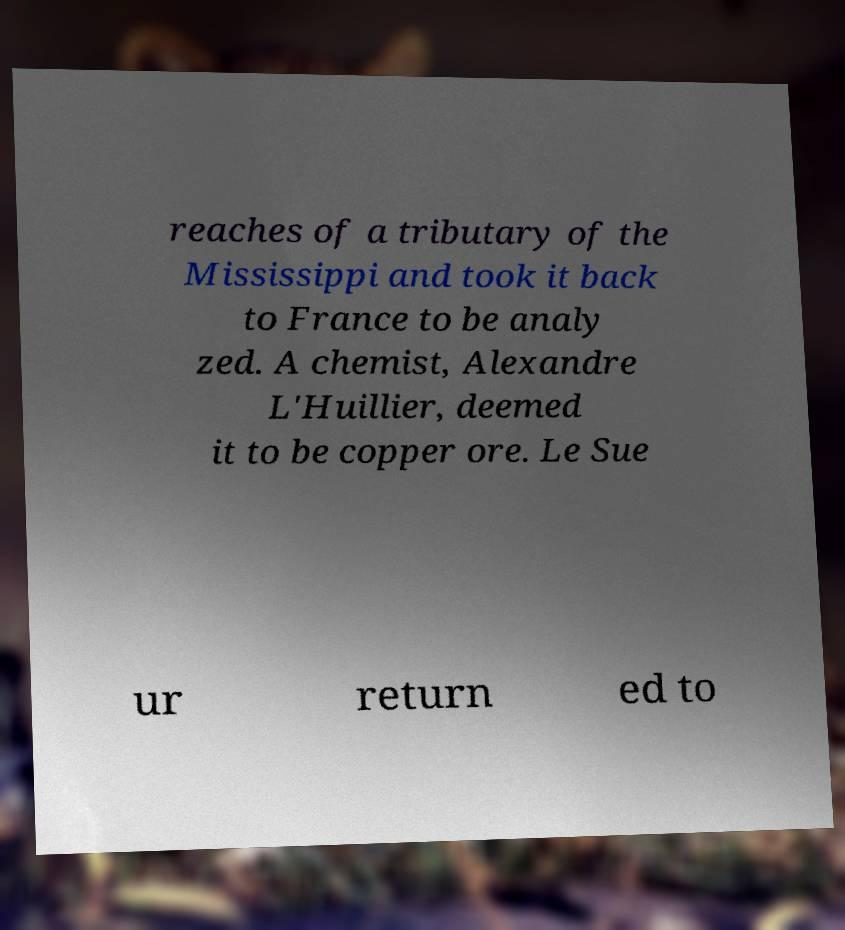For documentation purposes, I need the text within this image transcribed. Could you provide that? reaches of a tributary of the Mississippi and took it back to France to be analy zed. A chemist, Alexandre L'Huillier, deemed it to be copper ore. Le Sue ur return ed to 